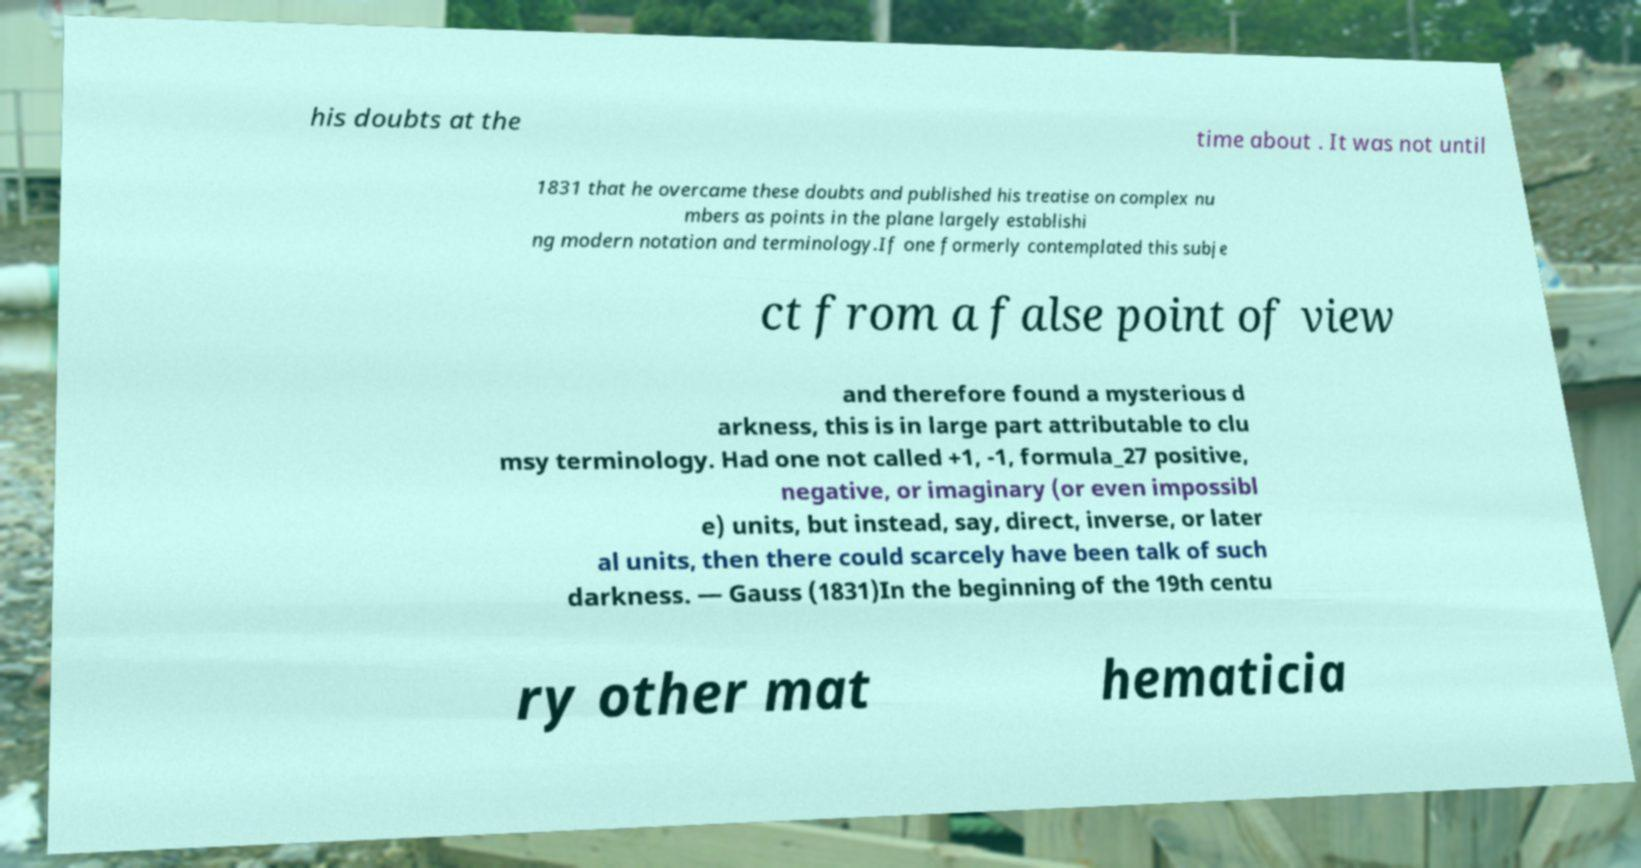Can you read and provide the text displayed in the image?This photo seems to have some interesting text. Can you extract and type it out for me? his doubts at the time about . It was not until 1831 that he overcame these doubts and published his treatise on complex nu mbers as points in the plane largely establishi ng modern notation and terminology.If one formerly contemplated this subje ct from a false point of view and therefore found a mysterious d arkness, this is in large part attributable to clu msy terminology. Had one not called +1, -1, formula_27 positive, negative, or imaginary (or even impossibl e) units, but instead, say, direct, inverse, or later al units, then there could scarcely have been talk of such darkness. — Gauss (1831)In the beginning of the 19th centu ry other mat hematicia 